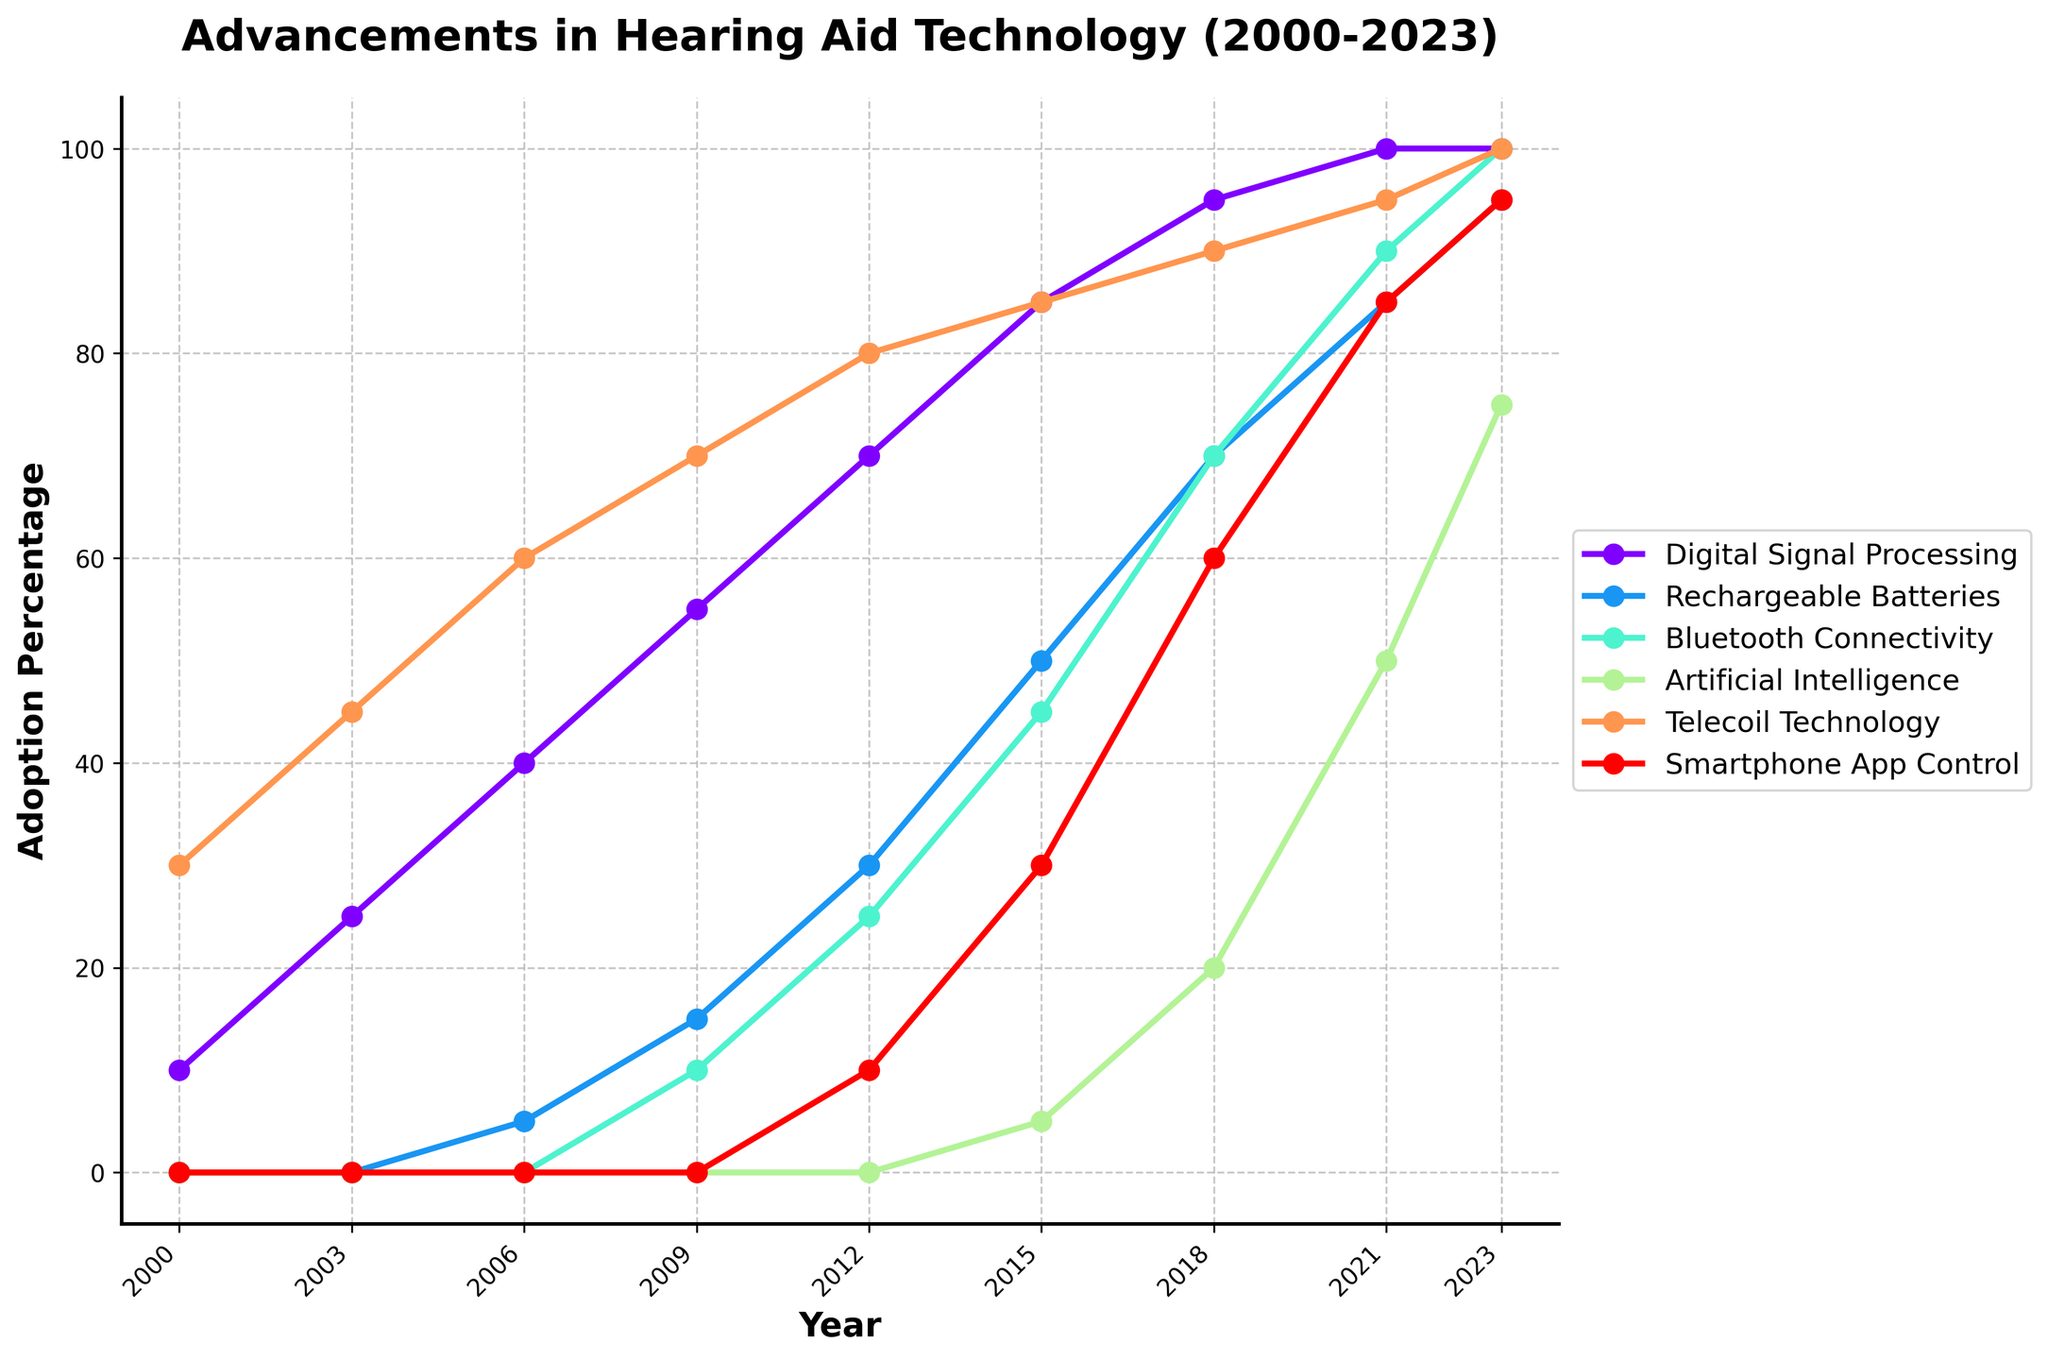Which feature shows the highest adoption percentage in 2000? Examine the values for all features in the year 2000. Note the percentages: Digital Signal Processing (10), Rechargeable Batteries (0), Bluetooth Connectivity (0), Artificial Intelligence (0), Telecoil Technology (30), and Smartphone App Control (0). Telecoil Technology has the highest adoption percentage.
Answer: Telecoil Technology Between which years did Digital Signal Processing see the most significant increase? Look at the values for Digital Signal Processing across all years. The most significant increase occurs between years with the largest value jump. From 2000 to 2003, it increased by 15 (10 to 25); from 2003 to 2006, it increased by 15 (25 to 40); from 2006 to 2009, it increased by 15 (40 to 55); from 2009 to 2012, it increased by 15 (55 to 70); from 2012 to 2015, it increased by 15 (70 to 85); from 2015 to 2018, it increased by 10 (85 to 95); and from 2018 to 2021, it increased by 5 (95 to 100).
Answer: 2000 to 2003 How many years did it take for Bluetooth Connectivity to reach an adoption percentage of 75? Identify the year when Bluetooth Connectivity reaches 75. It reaches 75 between 2021 (90) and 2023 (100). Bluetooth Connectivity started in a noticeable percentage in 2009.
Answer: 14 years What is the average adoption percentage of Smartphone App Control in 2021 and 2023? Note the values for Smartphone App Control in 2021 (85) and 2023 (95). Add them and divide by 2: (85 + 95) / 2.
Answer: 90 Which feature had a lower adoption percentage than Rechargeable Batteries in 2015? Look at the values of all features in 2015. Rechargeable Batteries has a value of 50. Comparing other features, Digital Signal Processing (85), Bluetooth Connectivity (45), Artificial Intelligence (5), Telecoil Technology (85), and Smartphone App Control (30). Only Artificial Intelligence and Smartphone App Control are lower.
Answer: Artificial Intelligence, Smartphone App Control From 2000 to 2018, which feature showed the least growth? Calculate the difference between 2018 and 2000 for all features. Digital Signal Processing (95-10=85), Rechargeable Batteries (70-0=70), Bluetooth Connectivity (70-0=70), Artificial Intelligence (20-0=20), Telecoil Technology (90-30=60), and Smartphone App Control (60-0=60). Artificial Intelligence showed the least growth.
Answer: Artificial Intelligence In which year did Artificial Intelligence adoption reach 50%? Find the year where Artificial Intelligence's value is 50. In the data, it reached 50 in 2021.
Answer: 2021 Compare the adoption percentage of Telecoil Technology in 2006 to Digital Signal Processing in 2009. Which is higher? Check the values: Telecoil Technology in 2006 is 60, and Digital Signal Processing in 2009 is 55. Telecoil Technology in 2006 is higher.
Answer: Telecoil Technology in 2006 What is the overall trend for Rechargeable Batteries from 2000 to 2023? Observe the values of Rechargeable Batteries over the years: 2000 (0), 2003 (0), 2006 (5), 2009 (15), 2012 (30), 2015 (50), 2018 (70), 2021 (85), 2023 (95). The trend is an increase throughout the years.
Answer: Increasing How does the 2023 adoption percentage of Bluetooth Connectivity compare to that of Telecoil Technology? Look at the values for 2023: Bluetooth Connectivity is 100, and Telecoil Technology is 100. Both are equal.
Answer: Equal 